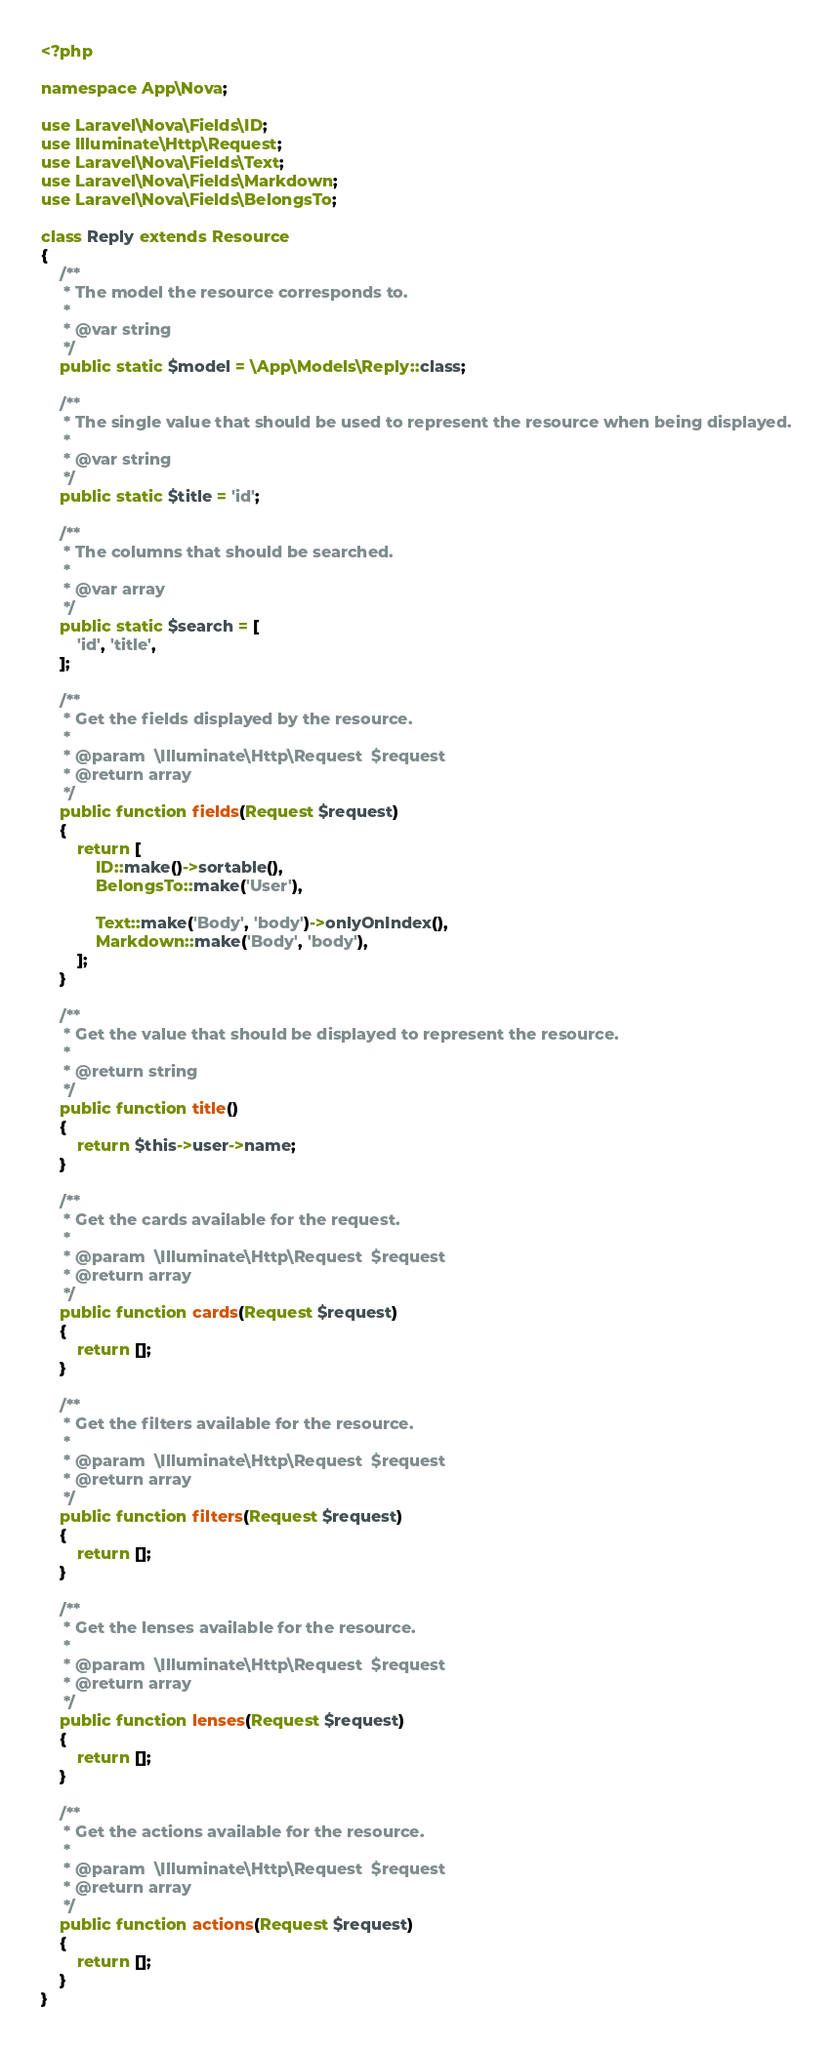<code> <loc_0><loc_0><loc_500><loc_500><_PHP_><?php

namespace App\Nova;

use Laravel\Nova\Fields\ID;
use Illuminate\Http\Request;
use Laravel\Nova\Fields\Text;
use Laravel\Nova\Fields\Markdown;
use Laravel\Nova\Fields\BelongsTo;

class Reply extends Resource
{
    /**
     * The model the resource corresponds to.
     *
     * @var string
     */
    public static $model = \App\Models\Reply::class;

    /**
     * The single value that should be used to represent the resource when being displayed.
     *
     * @var string
     */
    public static $title = 'id';

    /**
     * The columns that should be searched.
     *
     * @var array
     */
    public static $search = [
        'id', 'title',
    ];

    /**
     * Get the fields displayed by the resource.
     *
     * @param  \Illuminate\Http\Request  $request
     * @return array
     */
    public function fields(Request $request)
    {
        return [
            ID::make()->sortable(),
            BelongsTo::make('User'),

            Text::make('Body', 'body')->onlyOnIndex(),
            Markdown::make('Body', 'body'),
        ];
    }

    /**
     * Get the value that should be displayed to represent the resource.
     *
     * @return string
     */
    public function title()
    {
        return $this->user->name;
    }

    /**
     * Get the cards available for the request.
     *
     * @param  \Illuminate\Http\Request  $request
     * @return array
     */
    public function cards(Request $request)
    {
        return [];
    }

    /**
     * Get the filters available for the resource.
     *
     * @param  \Illuminate\Http\Request  $request
     * @return array
     */
    public function filters(Request $request)
    {
        return [];
    }

    /**
     * Get the lenses available for the resource.
     *
     * @param  \Illuminate\Http\Request  $request
     * @return array
     */
    public function lenses(Request $request)
    {
        return [];
    }

    /**
     * Get the actions available for the resource.
     *
     * @param  \Illuminate\Http\Request  $request
     * @return array
     */
    public function actions(Request $request)
    {
        return [];
    }
}
</code> 